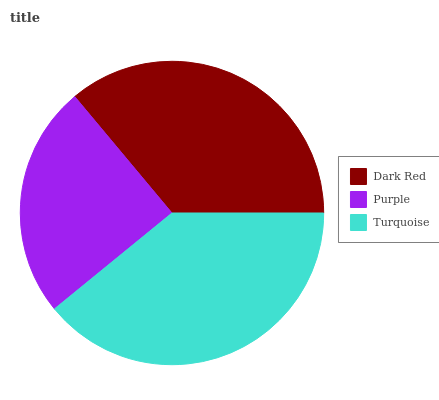Is Purple the minimum?
Answer yes or no. Yes. Is Turquoise the maximum?
Answer yes or no. Yes. Is Turquoise the minimum?
Answer yes or no. No. Is Purple the maximum?
Answer yes or no. No. Is Turquoise greater than Purple?
Answer yes or no. Yes. Is Purple less than Turquoise?
Answer yes or no. Yes. Is Purple greater than Turquoise?
Answer yes or no. No. Is Turquoise less than Purple?
Answer yes or no. No. Is Dark Red the high median?
Answer yes or no. Yes. Is Dark Red the low median?
Answer yes or no. Yes. Is Turquoise the high median?
Answer yes or no. No. Is Turquoise the low median?
Answer yes or no. No. 